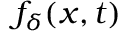<formula> <loc_0><loc_0><loc_500><loc_500>f _ { \delta } ( x , t )</formula> 